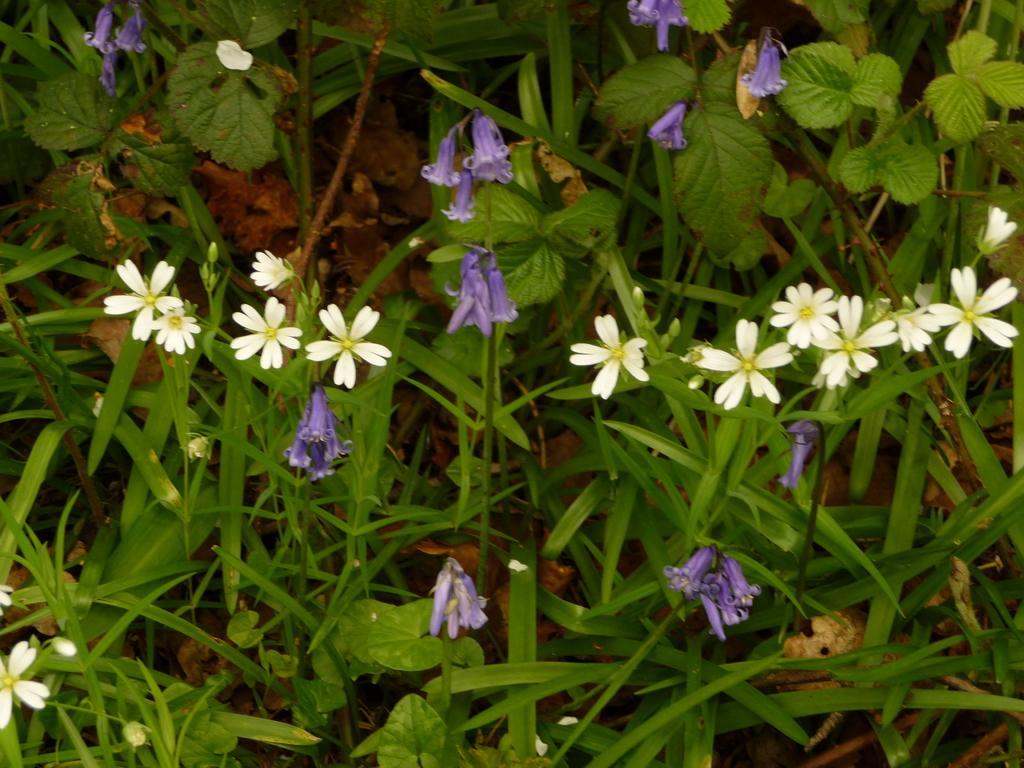Please provide a concise description of this image. In the picture I can see flower plants. This flowers are white and purple in color. 